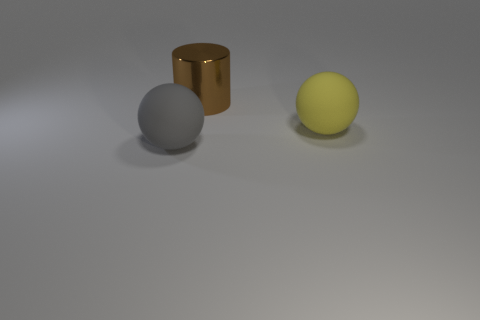Add 1 tiny cylinders. How many objects exist? 4 Subtract all balls. How many objects are left? 1 Subtract all big matte balls. Subtract all big yellow things. How many objects are left? 0 Add 3 large brown metallic cylinders. How many large brown metallic cylinders are left? 4 Add 2 red cylinders. How many red cylinders exist? 2 Subtract 0 purple spheres. How many objects are left? 3 